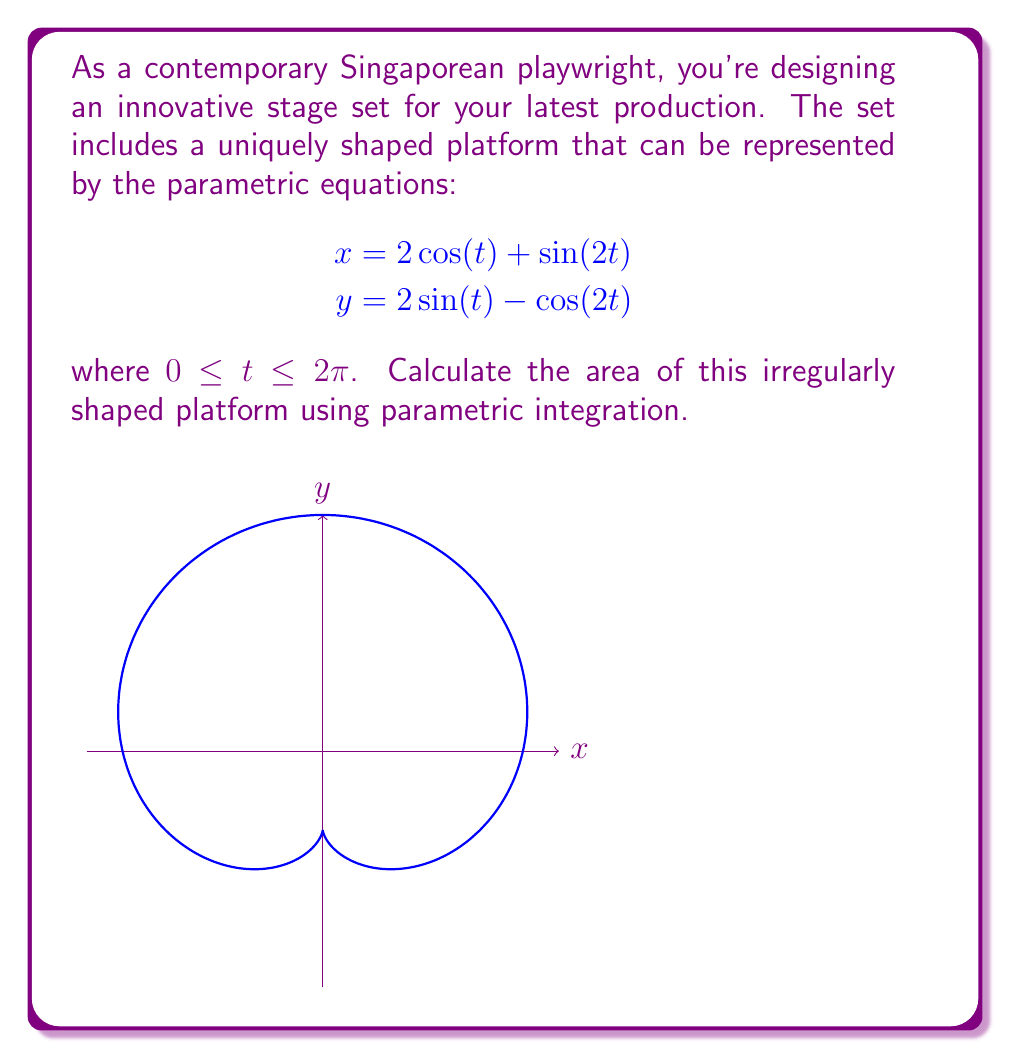Can you answer this question? To calculate the area enclosed by a parametric curve, we can use the formula:

$$\text{Area} = \frac{1}{2}\int_a^b [x(t)\frac{dy}{dt} - y(t)\frac{dx}{dt}] dt$$

where $a$ and $b$ are the start and end values of the parameter $t$.

Step 1: Calculate $\frac{dx}{dt}$ and $\frac{dy}{dt}$
$$\frac{dx}{dt} = -2\sin(t) + 2\cos(2t)$$
$$\frac{dy}{dt} = 2\cos(t) + 2\sin(2t)$$

Step 2: Substitute these values into the area formula
$$\text{Area} = \frac{1}{2}\int_0^{2\pi} [(2\cos(t) + \sin(2t))(2\cos(t) + 2\sin(2t)) - (2\sin(t) - \cos(2t))(-2\sin(t) + 2\cos(2t))] dt$$

Step 3: Expand the integrand
$$\text{Area} = \frac{1}{2}\int_0^{2\pi} [4\cos^2(t) + 4\cos(t)\sin(2t) + 2\sin(2t)\cos(t) + 2\sin^2(2t) + 4\sin^2(t) - 4\sin(t)\cos(2t) - 2\cos(2t)\sin(t) + 2\cos^2(2t)] dt$$

Step 4: Simplify using trigonometric identities
$$\text{Area} = \frac{1}{2}\int_0^{2\pi} [4\cos^2(t) + 6\cos(t)\sin(2t) + 4\sin^2(t) - 6\sin(t)\cos(2t) + 2\sin^2(2t) + 2\cos^2(2t)] dt$$
$$= \frac{1}{2}\int_0^{2\pi} [4 + 6\cos(t)\sin(2t) - 6\sin(t)\cos(2t) + 2] dt$$
$$= \frac{1}{2}\int_0^{2\pi} [6 + 6(\cos(t)\sin(2t) - \sin(t)\cos(2t))] dt$$

Step 5: Evaluate the integral
$$\text{Area} = \frac{1}{2}[6t + 6(-\cos(3t))]_0^{2\pi}$$
$$= \frac{1}{2}[12\pi + 6(\cos(0) - \cos(6\pi))]$$
$$= \frac{1}{2}[12\pi + 6(1 - 1)]$$
$$= 6\pi$$

Therefore, the area of the irregularly shaped platform is $6\pi$ square units.
Answer: $6\pi$ square units 